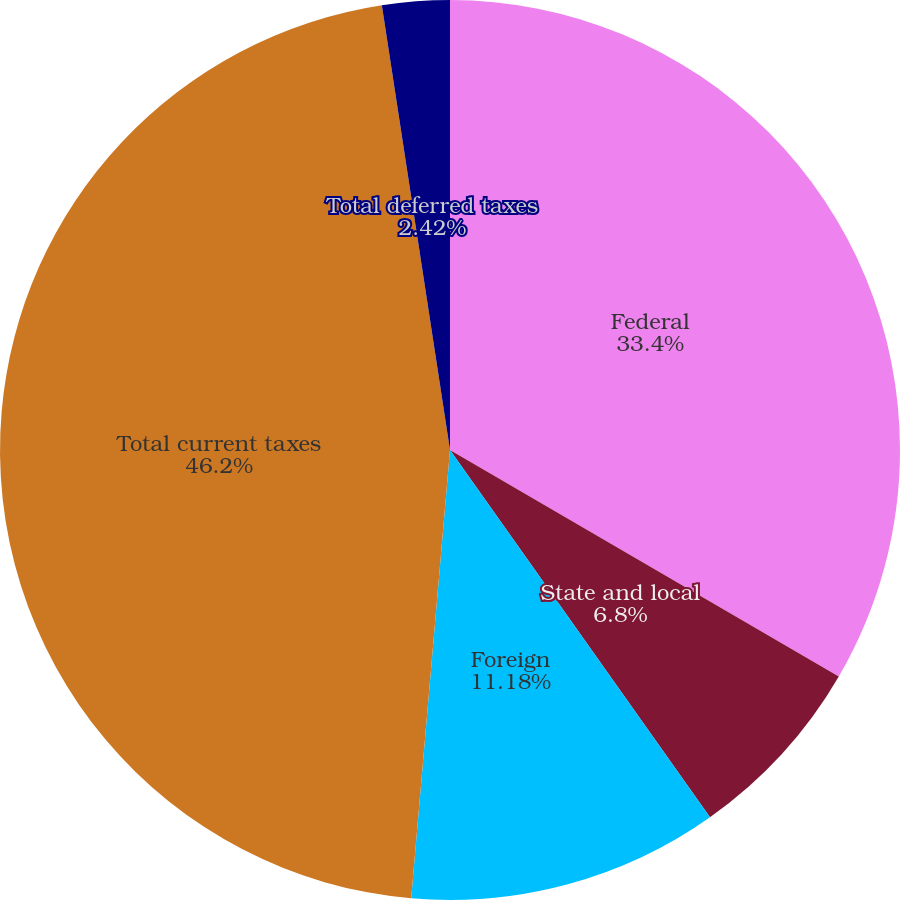Convert chart. <chart><loc_0><loc_0><loc_500><loc_500><pie_chart><fcel>Federal<fcel>State and local<fcel>Foreign<fcel>Total current taxes<fcel>Total deferred taxes<nl><fcel>33.4%<fcel>6.8%<fcel>11.18%<fcel>46.21%<fcel>2.42%<nl></chart> 